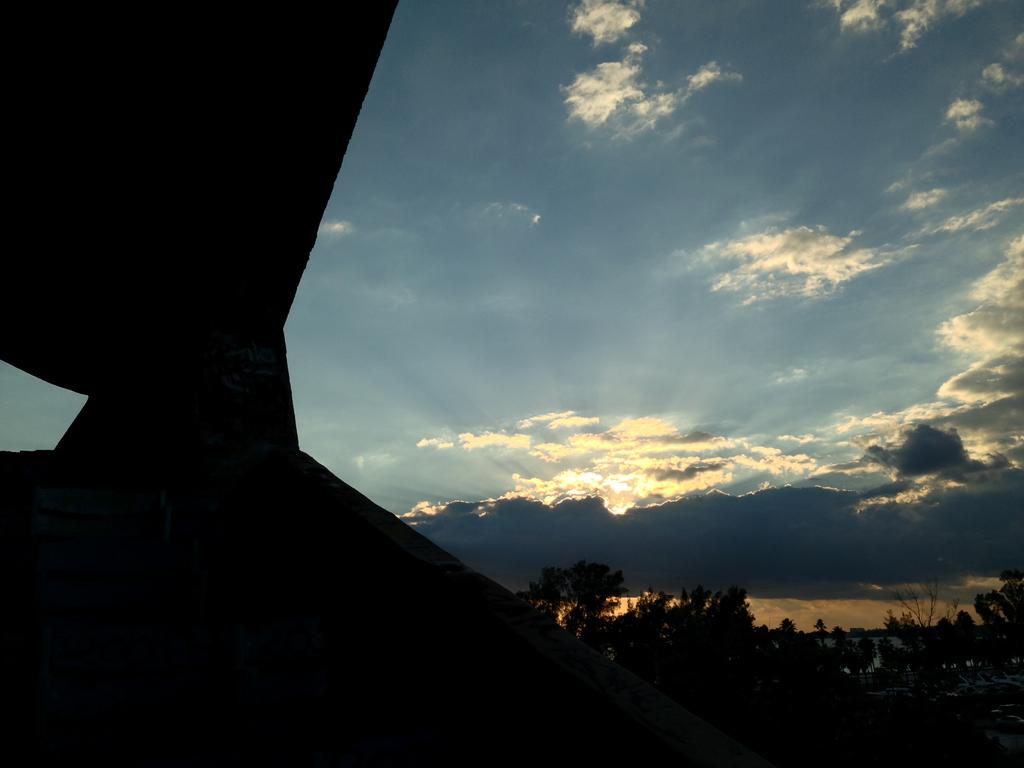What is the main subject in the foreground of the image? There is an object in the foreground of the image. What is the color of the object in the image? The object is black in color. What can be seen in the background of the image? There are trees and the sky visible in the background of the image. What type of pets can be seen playing with the plough in the image? There is no plough or pets present in the image. 